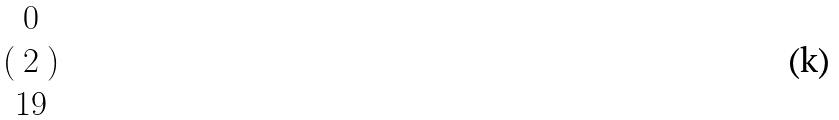<formula> <loc_0><loc_0><loc_500><loc_500>( \begin{matrix} 0 \\ 2 \\ 1 9 \end{matrix} )</formula> 